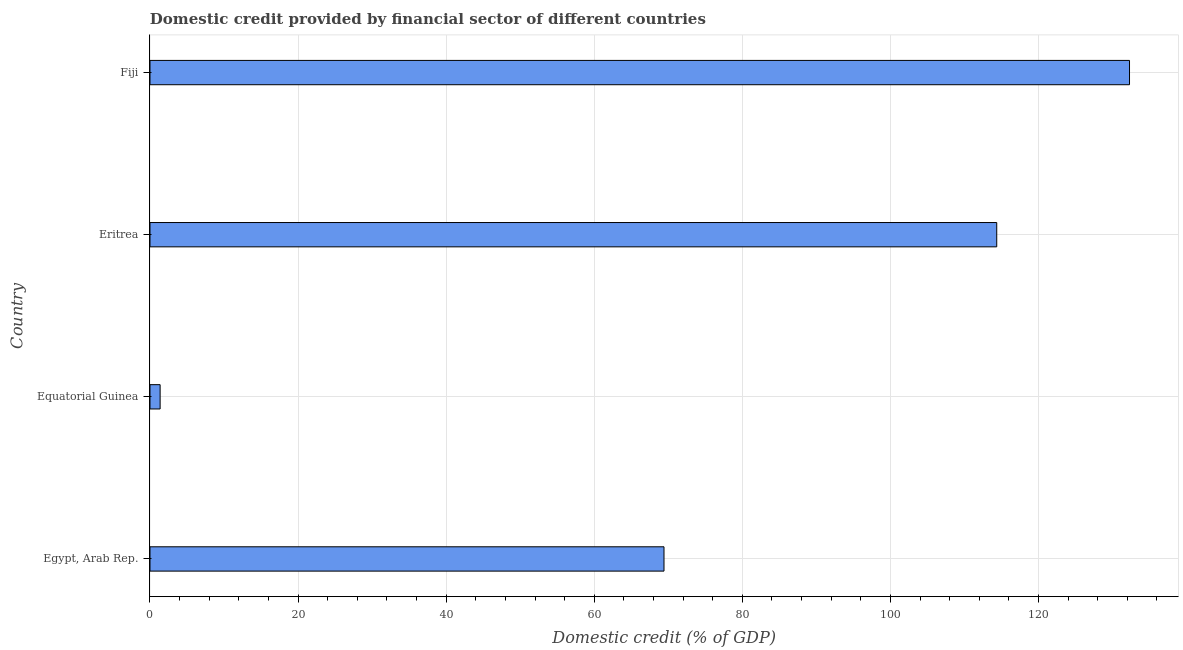Does the graph contain grids?
Give a very brief answer. Yes. What is the title of the graph?
Offer a very short reply. Domestic credit provided by financial sector of different countries. What is the label or title of the X-axis?
Your answer should be compact. Domestic credit (% of GDP). What is the label or title of the Y-axis?
Your answer should be very brief. Country. What is the domestic credit provided by financial sector in Fiji?
Make the answer very short. 132.3. Across all countries, what is the maximum domestic credit provided by financial sector?
Ensure brevity in your answer.  132.3. Across all countries, what is the minimum domestic credit provided by financial sector?
Make the answer very short. 1.37. In which country was the domestic credit provided by financial sector maximum?
Provide a succinct answer. Fiji. In which country was the domestic credit provided by financial sector minimum?
Make the answer very short. Equatorial Guinea. What is the sum of the domestic credit provided by financial sector?
Keep it short and to the point. 317.45. What is the difference between the domestic credit provided by financial sector in Egypt, Arab Rep. and Eritrea?
Your answer should be very brief. -44.94. What is the average domestic credit provided by financial sector per country?
Your answer should be very brief. 79.36. What is the median domestic credit provided by financial sector?
Offer a terse response. 91.89. What is the ratio of the domestic credit provided by financial sector in Egypt, Arab Rep. to that in Eritrea?
Your answer should be very brief. 0.61. Is the domestic credit provided by financial sector in Egypt, Arab Rep. less than that in Fiji?
Provide a short and direct response. Yes. What is the difference between the highest and the second highest domestic credit provided by financial sector?
Offer a very short reply. 17.93. Is the sum of the domestic credit provided by financial sector in Egypt, Arab Rep. and Eritrea greater than the maximum domestic credit provided by financial sector across all countries?
Make the answer very short. Yes. What is the difference between the highest and the lowest domestic credit provided by financial sector?
Offer a very short reply. 130.93. In how many countries, is the domestic credit provided by financial sector greater than the average domestic credit provided by financial sector taken over all countries?
Ensure brevity in your answer.  2. Are all the bars in the graph horizontal?
Keep it short and to the point. Yes. What is the Domestic credit (% of GDP) of Egypt, Arab Rep.?
Make the answer very short. 69.42. What is the Domestic credit (% of GDP) of Equatorial Guinea?
Make the answer very short. 1.37. What is the Domestic credit (% of GDP) in Eritrea?
Keep it short and to the point. 114.36. What is the Domestic credit (% of GDP) in Fiji?
Your answer should be very brief. 132.3. What is the difference between the Domestic credit (% of GDP) in Egypt, Arab Rep. and Equatorial Guinea?
Make the answer very short. 68.05. What is the difference between the Domestic credit (% of GDP) in Egypt, Arab Rep. and Eritrea?
Offer a terse response. -44.94. What is the difference between the Domestic credit (% of GDP) in Egypt, Arab Rep. and Fiji?
Give a very brief answer. -62.87. What is the difference between the Domestic credit (% of GDP) in Equatorial Guinea and Eritrea?
Your response must be concise. -112.99. What is the difference between the Domestic credit (% of GDP) in Equatorial Guinea and Fiji?
Offer a terse response. -130.93. What is the difference between the Domestic credit (% of GDP) in Eritrea and Fiji?
Ensure brevity in your answer.  -17.93. What is the ratio of the Domestic credit (% of GDP) in Egypt, Arab Rep. to that in Equatorial Guinea?
Provide a short and direct response. 50.69. What is the ratio of the Domestic credit (% of GDP) in Egypt, Arab Rep. to that in Eritrea?
Keep it short and to the point. 0.61. What is the ratio of the Domestic credit (% of GDP) in Egypt, Arab Rep. to that in Fiji?
Provide a succinct answer. 0.53. What is the ratio of the Domestic credit (% of GDP) in Equatorial Guinea to that in Eritrea?
Your response must be concise. 0.01. What is the ratio of the Domestic credit (% of GDP) in Equatorial Guinea to that in Fiji?
Offer a terse response. 0.01. What is the ratio of the Domestic credit (% of GDP) in Eritrea to that in Fiji?
Your answer should be compact. 0.86. 